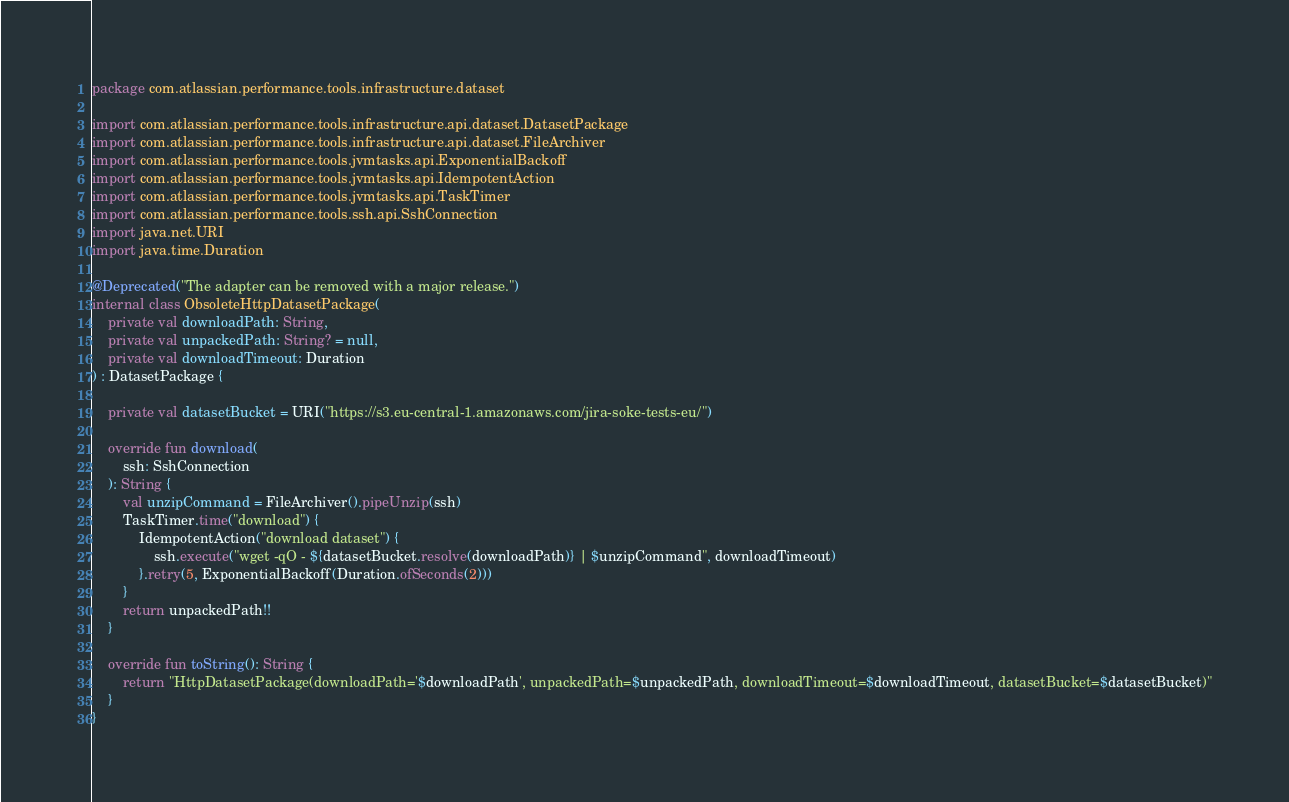<code> <loc_0><loc_0><loc_500><loc_500><_Kotlin_>package com.atlassian.performance.tools.infrastructure.dataset

import com.atlassian.performance.tools.infrastructure.api.dataset.DatasetPackage
import com.atlassian.performance.tools.infrastructure.api.dataset.FileArchiver
import com.atlassian.performance.tools.jvmtasks.api.ExponentialBackoff
import com.atlassian.performance.tools.jvmtasks.api.IdempotentAction
import com.atlassian.performance.tools.jvmtasks.api.TaskTimer
import com.atlassian.performance.tools.ssh.api.SshConnection
import java.net.URI
import java.time.Duration

@Deprecated("The adapter can be removed with a major release.")
internal class ObsoleteHttpDatasetPackage(
    private val downloadPath: String,
    private val unpackedPath: String? = null,
    private val downloadTimeout: Duration
) : DatasetPackage {

    private val datasetBucket = URI("https://s3.eu-central-1.amazonaws.com/jira-soke-tests-eu/")

    override fun download(
        ssh: SshConnection
    ): String {
        val unzipCommand = FileArchiver().pipeUnzip(ssh)
        TaskTimer.time("download") {
            IdempotentAction("download dataset") {
                ssh.execute("wget -qO - ${datasetBucket.resolve(downloadPath)} | $unzipCommand", downloadTimeout)
            }.retry(5, ExponentialBackoff(Duration.ofSeconds(2)))
        }
        return unpackedPath!!
    }

    override fun toString(): String {
        return "HttpDatasetPackage(downloadPath='$downloadPath', unpackedPath=$unpackedPath, downloadTimeout=$downloadTimeout, datasetBucket=$datasetBucket)"
    }
}
</code> 